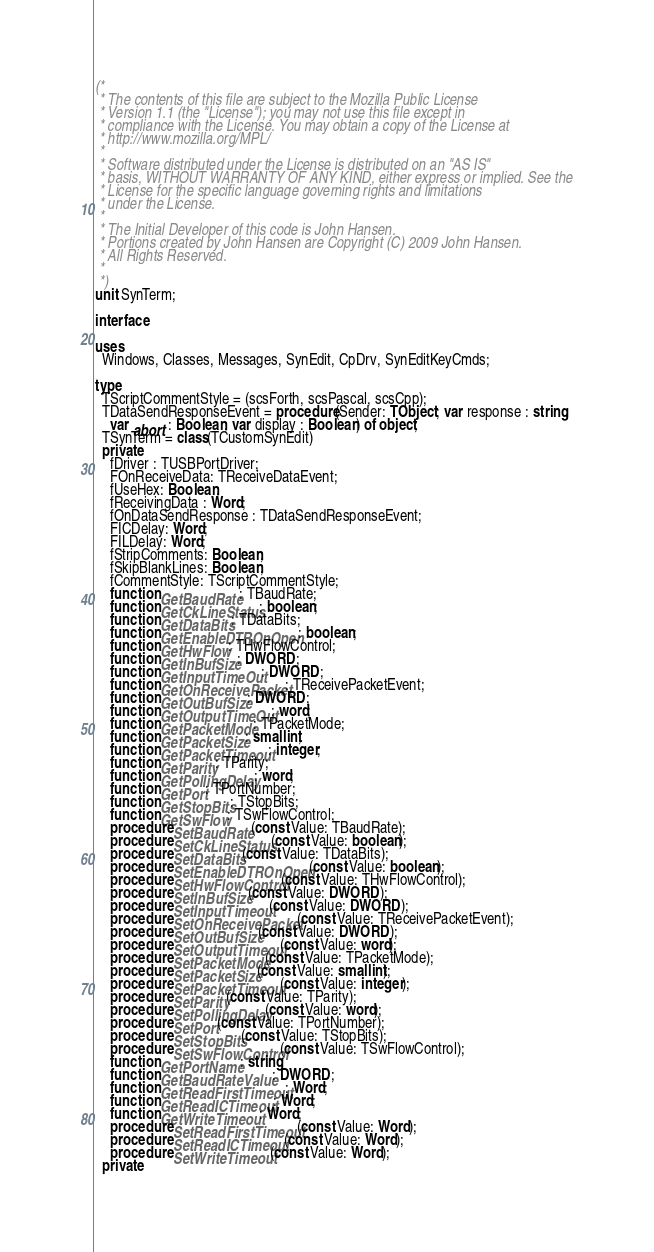<code> <loc_0><loc_0><loc_500><loc_500><_Pascal_>(*
 * The contents of this file are subject to the Mozilla Public License
 * Version 1.1 (the "License"); you may not use this file except in
 * compliance with the License. You may obtain a copy of the License at
 * http://www.mozilla.org/MPL/
 *
 * Software distributed under the License is distributed on an "AS IS"
 * basis, WITHOUT WARRANTY OF ANY KIND, either express or implied. See the
 * License for the specific language governing rights and limitations
 * under the License.
 *
 * The Initial Developer of this code is John Hansen.
 * Portions created by John Hansen are Copyright (C) 2009 John Hansen.
 * All Rights Reserved.
 *
 *)
unit SynTerm;

interface

uses
  Windows, Classes, Messages, SynEdit, CpDrv, SynEditKeyCmds;

type
  TScriptCommentStyle = (scsForth, scsPascal, scsCpp);
  TDataSendResponseEvent = procedure(Sender: TObject; var response : string;
    var abort : Boolean; var display : Boolean) of object;
  TSynTerm = class(TCustomSynEdit)
  private
    fDriver : TUSBPortDriver;
    FOnReceiveData: TReceiveDataEvent;
    fUseHex: Boolean;
    fReceivingData : Word;
    fOnDataSendResponse : TDataSendResponseEvent;
    FICDelay: Word;
    FILDelay: Word;
    fStripComments: Boolean;
    fSkipBlankLines: Boolean;
    fCommentStyle: TScriptCommentStyle;
    function GetBaudRate: TBaudRate;
    function GetCkLineStatus: boolean;
    function GetDataBits: TDataBits;
    function GetEnableDTROnOpen: boolean;
    function GetHwFlow: THwFlowControl;
    function GetInBufSize: DWORD;
    function GetInputTimeOut: DWORD;
    function GetOnReceivePacket: TReceivePacketEvent;
    function GetOutBufSize: DWORD;
    function GetOutputTimeOut: word;
    function GetPacketMode: TPacketMode;
    function GetPacketSize: smallint;
    function GetPacketTimeout: integer;
    function GetParity: TParity;
    function GetPollingDelay: word;
    function GetPort: TPortNumber;
    function GetStopBits: TStopBits;
    function GetSwFlow: TSwFlowControl;
    procedure SetBaudRate(const Value: TBaudRate);
    procedure SetCkLineStatus(const Value: boolean);
    procedure SetDataBits(const Value: TDataBits);
    procedure SetEnableDTROnOpen(const Value: boolean);
    procedure SetHwFlowControl(const Value: THwFlowControl);
    procedure SetInBufSize(const Value: DWORD);
    procedure SetInputTimeout(const Value: DWORD);
    procedure SetOnReceivePacket(const Value: TReceivePacketEvent);
    procedure SetOutBufSize(const Value: DWORD);
    procedure SetOutputTimeout(const Value: word);
    procedure SetPacketMode(const Value: TPacketMode);
    procedure SetPacketSize(const Value: smallint);
    procedure SetPacketTimeout(const Value: integer);
    procedure SetParity(const Value: TParity);
    procedure SetPollingDelay(const Value: word);
    procedure SetPort(const Value: TPortNumber);
    procedure SetStopBits(const Value: TStopBits);
    procedure SetSwFlowControl(const Value: TSwFlowControl);
    function GetPortName: string;
    function GetBaudRateValue: DWORD;
    function GetReadFirstTimeout: Word;
    function GetReadICTimeout: Word;
    function GetWriteTimeout: Word;
    procedure SetReadFirstTimeout(const Value: Word);
    procedure SetReadICTimeout(const Value: Word);
    procedure SetWriteTimeout(const Value: Word);
  private</code> 